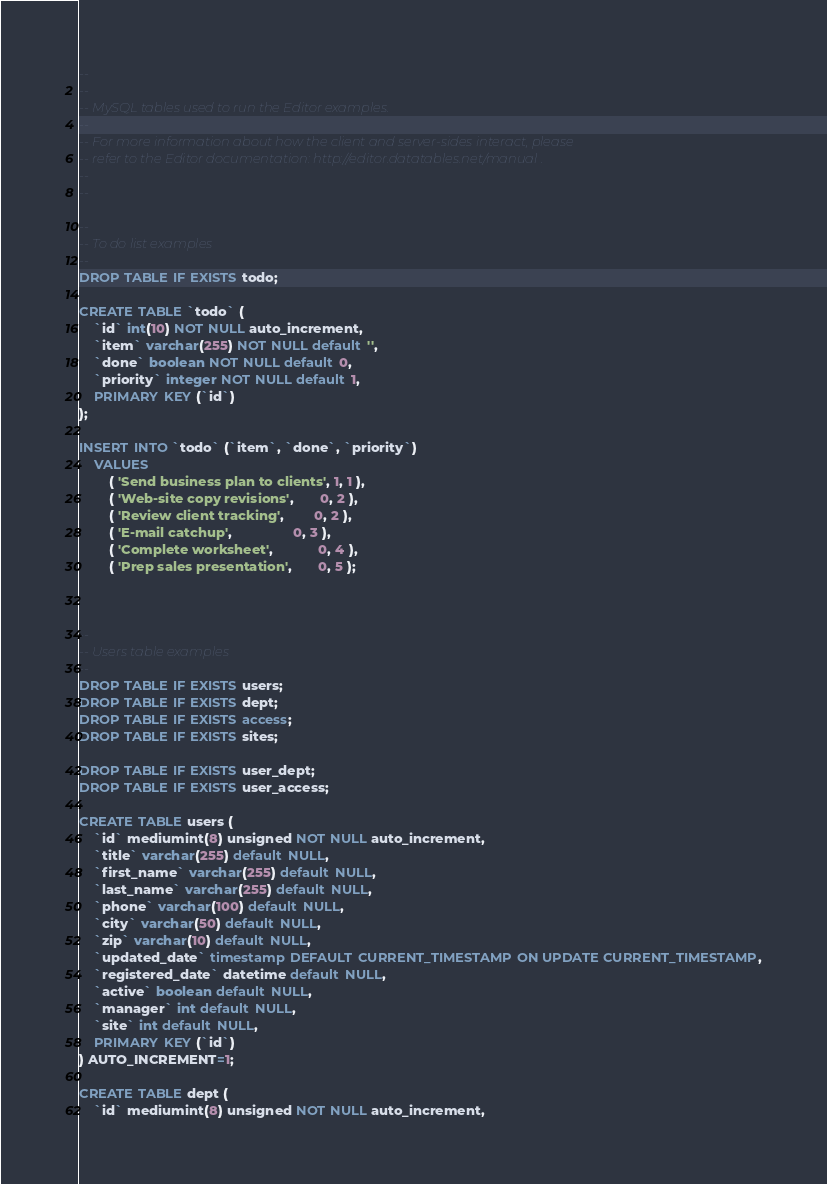Convert code to text. <code><loc_0><loc_0><loc_500><loc_500><_SQL_>--
--
-- MySQL tables used to run the Editor examples.
--
-- For more information about how the client and server-sides interact, please
-- refer to the Editor documentation: http://editor.datatables.net/manual .
--
--

--
-- To do list examples
--
DROP TABLE IF EXISTS todo;

CREATE TABLE `todo` (
    `id` int(10) NOT NULL auto_increment,
    `item` varchar(255) NOT NULL default '',
    `done` boolean NOT NULL default 0,
    `priority` integer NOT NULL default 1,
    PRIMARY KEY (`id`)
);

INSERT INTO `todo` (`item`, `done`, `priority`)
    VALUES
        ( 'Send business plan to clients', 1, 1 ),
        ( 'Web-site copy revisions',       0, 2 ),
        ( 'Review client tracking',        0, 2 ),
        ( 'E-mail catchup',                0, 3 ),
        ( 'Complete worksheet',            0, 4 ),
        ( 'Prep sales presentation',       0, 5 );



--
-- Users table examples
--
DROP TABLE IF EXISTS users;
DROP TABLE IF EXISTS dept;
DROP TABLE IF EXISTS access;
DROP TABLE IF EXISTS sites;

DROP TABLE IF EXISTS user_dept;
DROP TABLE IF EXISTS user_access;

CREATE TABLE users (
    `id` mediumint(8) unsigned NOT NULL auto_increment, 
    `title` varchar(255) default NULL,
    `first_name` varchar(255) default NULL,
    `last_name` varchar(255) default NULL,
    `phone` varchar(100) default NULL,
    `city` varchar(50) default NULL,
    `zip` varchar(10) default NULL,
    `updated_date` timestamp DEFAULT CURRENT_TIMESTAMP ON UPDATE CURRENT_TIMESTAMP,
    `registered_date` datetime default NULL,
    `active` boolean default NULL,
    `manager` int default NULL,
    `site` int default NULL,
    PRIMARY KEY (`id`)
) AUTO_INCREMENT=1; 

CREATE TABLE dept (
    `id` mediumint(8) unsigned NOT NULL auto_increment, </code> 